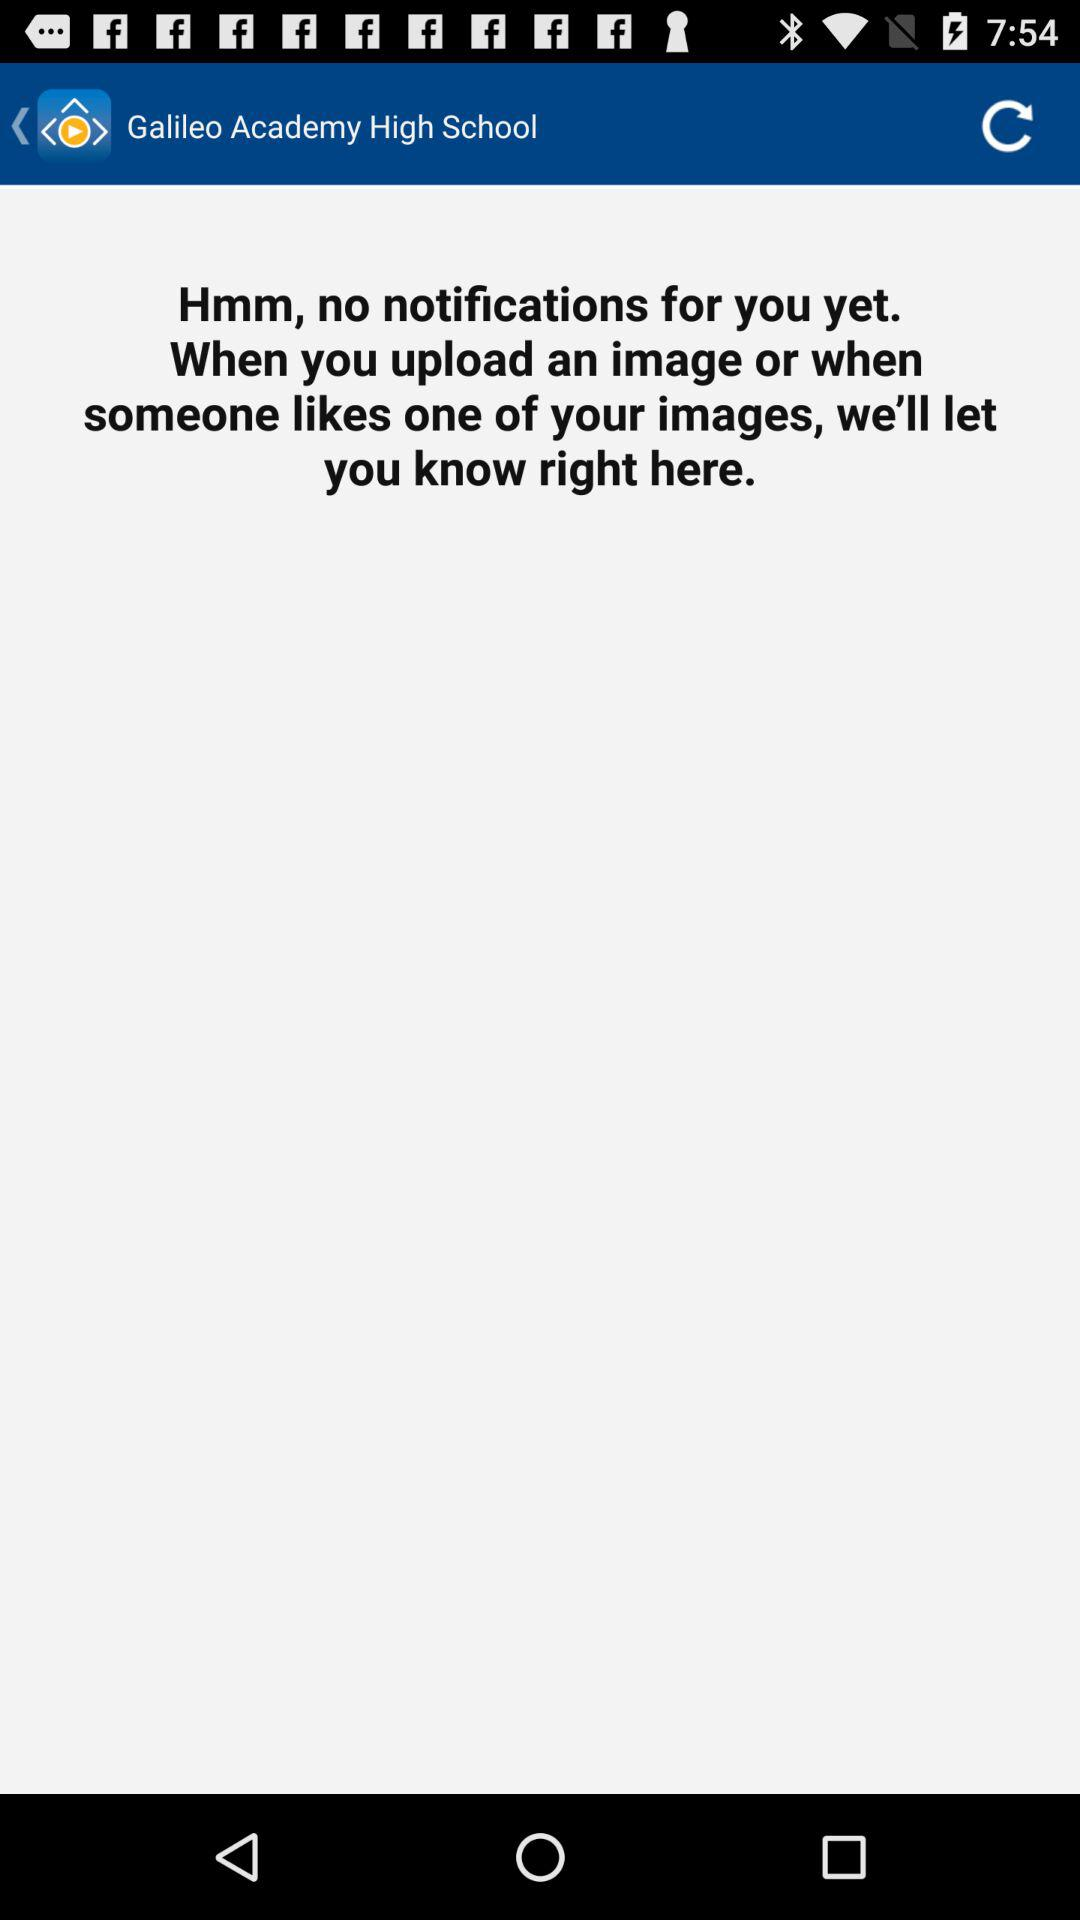How many notifications does the user have?
Answer the question using a single word or phrase. 0 